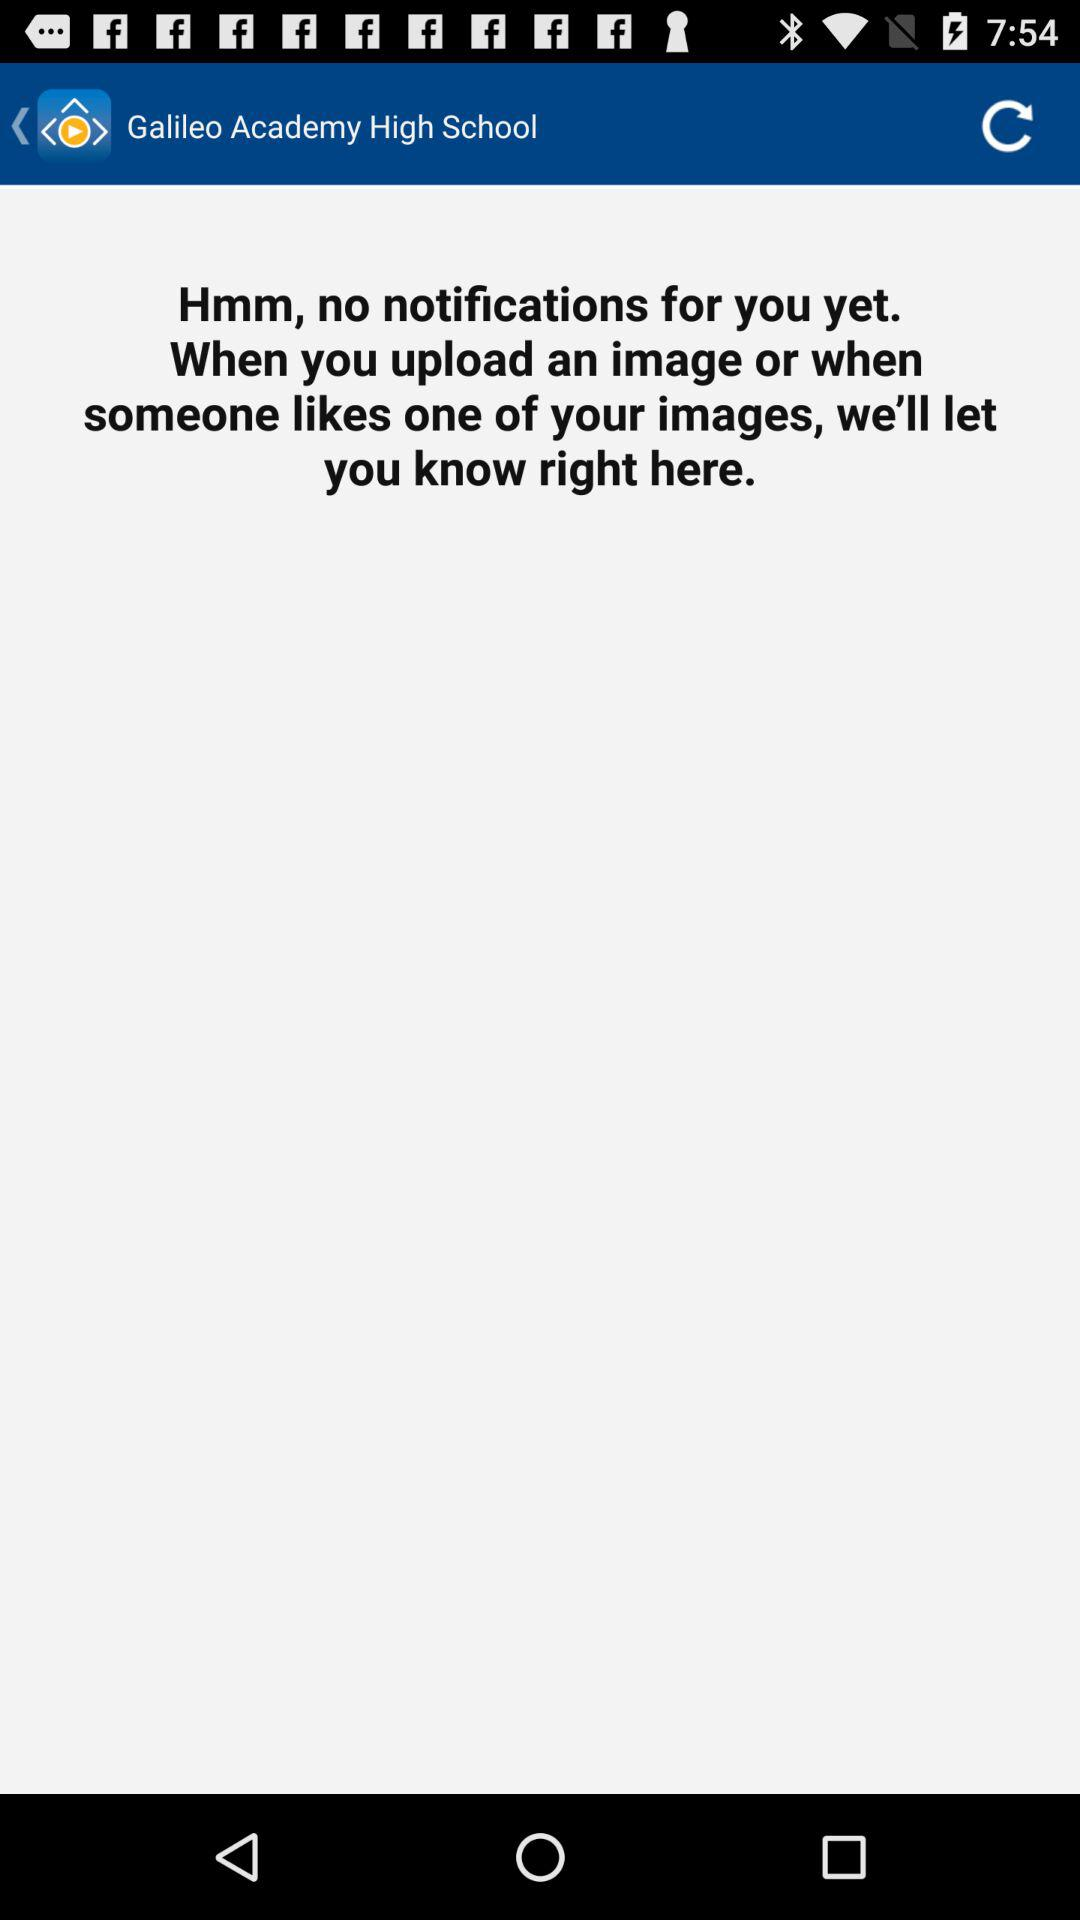How many notifications does the user have?
Answer the question using a single word or phrase. 0 